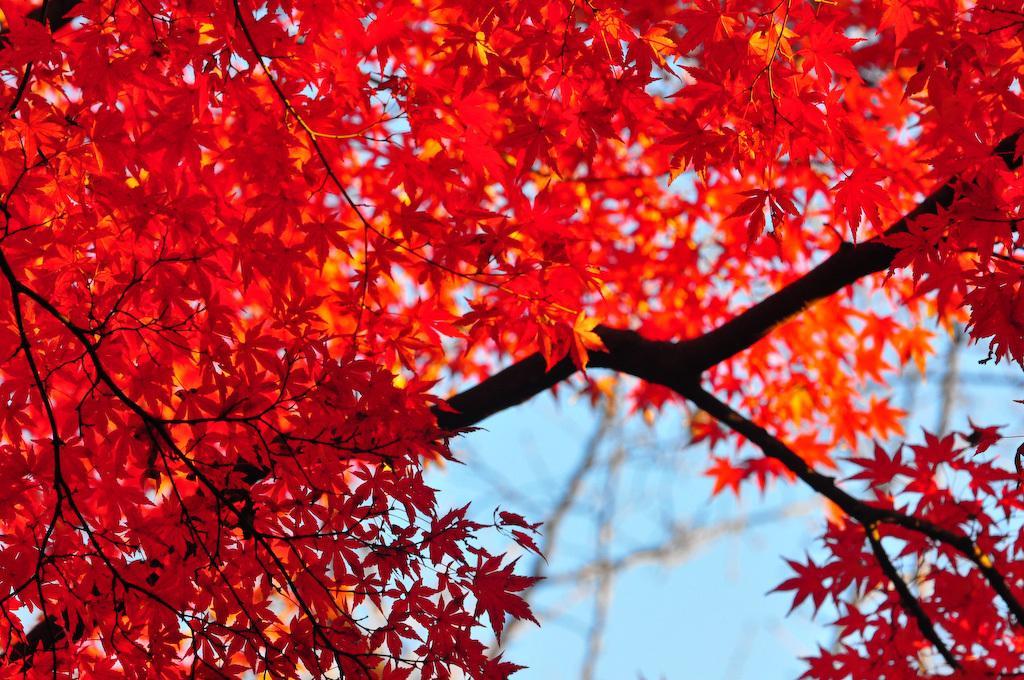Please provide a concise description of this image. In this picture I can see there is a tree, it has branches and leaves. The sky is clear. 